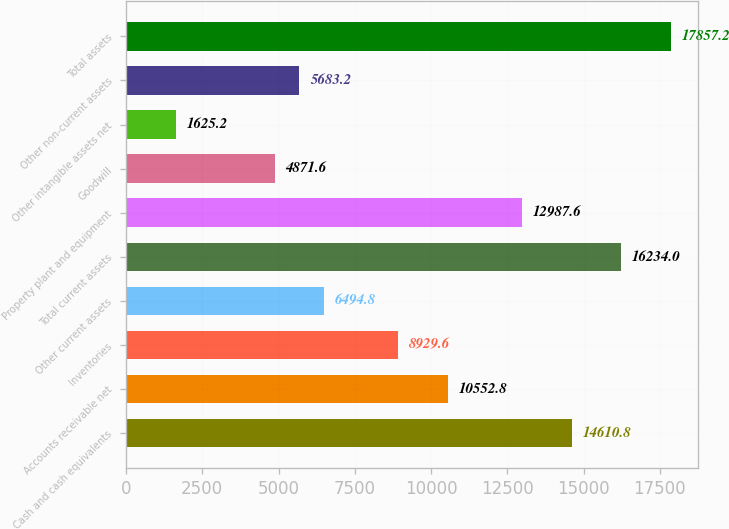<chart> <loc_0><loc_0><loc_500><loc_500><bar_chart><fcel>Cash and cash equivalents<fcel>Accounts receivable net<fcel>Inventories<fcel>Other current assets<fcel>Total current assets<fcel>Property plant and equipment<fcel>Goodwill<fcel>Other intangible assets net<fcel>Other non-current assets<fcel>Total assets<nl><fcel>14610.8<fcel>10552.8<fcel>8929.6<fcel>6494.8<fcel>16234<fcel>12987.6<fcel>4871.6<fcel>1625.2<fcel>5683.2<fcel>17857.2<nl></chart> 